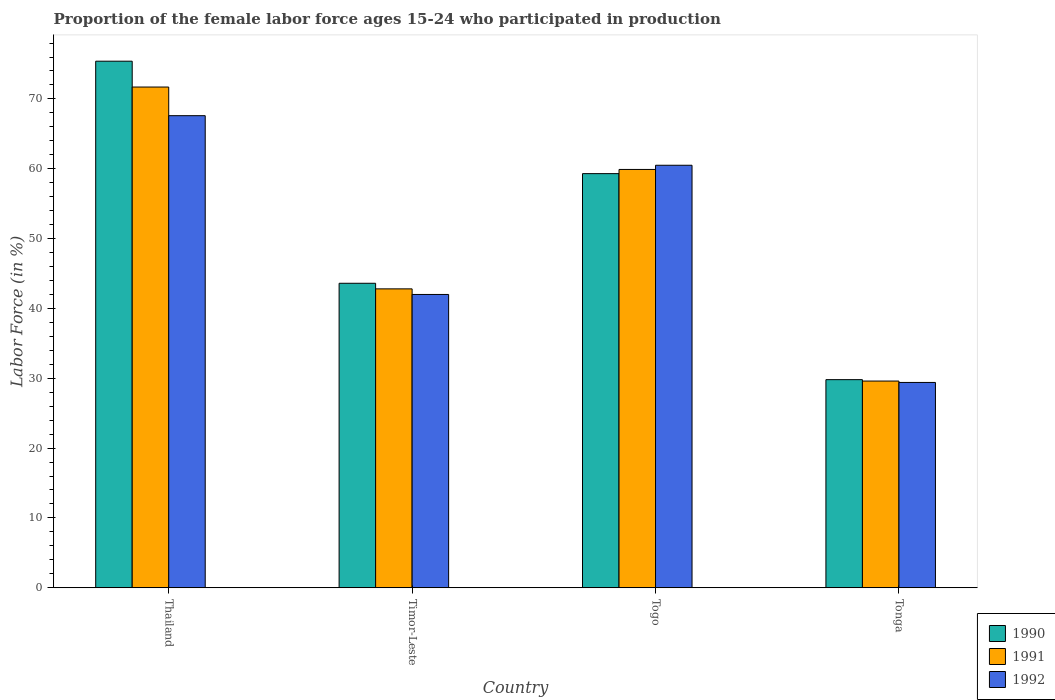How many different coloured bars are there?
Give a very brief answer. 3. Are the number of bars per tick equal to the number of legend labels?
Ensure brevity in your answer.  Yes. Are the number of bars on each tick of the X-axis equal?
Make the answer very short. Yes. How many bars are there on the 2nd tick from the left?
Give a very brief answer. 3. What is the label of the 4th group of bars from the left?
Provide a succinct answer. Tonga. In how many cases, is the number of bars for a given country not equal to the number of legend labels?
Your answer should be very brief. 0. What is the proportion of the female labor force who participated in production in 1990 in Timor-Leste?
Provide a succinct answer. 43.6. Across all countries, what is the maximum proportion of the female labor force who participated in production in 1992?
Give a very brief answer. 67.6. Across all countries, what is the minimum proportion of the female labor force who participated in production in 1990?
Provide a short and direct response. 29.8. In which country was the proportion of the female labor force who participated in production in 1991 maximum?
Provide a succinct answer. Thailand. In which country was the proportion of the female labor force who participated in production in 1991 minimum?
Offer a terse response. Tonga. What is the total proportion of the female labor force who participated in production in 1992 in the graph?
Offer a terse response. 199.5. What is the difference between the proportion of the female labor force who participated in production in 1990 in Thailand and that in Togo?
Offer a very short reply. 16.1. What is the difference between the proportion of the female labor force who participated in production in 1992 in Tonga and the proportion of the female labor force who participated in production in 1991 in Togo?
Provide a short and direct response. -30.5. What is the average proportion of the female labor force who participated in production in 1990 per country?
Your answer should be very brief. 52.02. What is the difference between the proportion of the female labor force who participated in production of/in 1990 and proportion of the female labor force who participated in production of/in 1992 in Thailand?
Your response must be concise. 7.8. In how many countries, is the proportion of the female labor force who participated in production in 1991 greater than 20 %?
Give a very brief answer. 4. What is the ratio of the proportion of the female labor force who participated in production in 1990 in Thailand to that in Tonga?
Your answer should be compact. 2.53. Is the difference between the proportion of the female labor force who participated in production in 1990 in Timor-Leste and Togo greater than the difference between the proportion of the female labor force who participated in production in 1992 in Timor-Leste and Togo?
Offer a very short reply. Yes. What is the difference between the highest and the second highest proportion of the female labor force who participated in production in 1991?
Offer a terse response. -17.1. What is the difference between the highest and the lowest proportion of the female labor force who participated in production in 1992?
Provide a succinct answer. 38.2. How many bars are there?
Give a very brief answer. 12. Are all the bars in the graph horizontal?
Your answer should be very brief. No. Does the graph contain any zero values?
Your answer should be very brief. No. Where does the legend appear in the graph?
Give a very brief answer. Bottom right. How are the legend labels stacked?
Your answer should be compact. Vertical. What is the title of the graph?
Provide a succinct answer. Proportion of the female labor force ages 15-24 who participated in production. What is the label or title of the Y-axis?
Make the answer very short. Labor Force (in %). What is the Labor Force (in %) in 1990 in Thailand?
Make the answer very short. 75.4. What is the Labor Force (in %) in 1991 in Thailand?
Ensure brevity in your answer.  71.7. What is the Labor Force (in %) of 1992 in Thailand?
Provide a short and direct response. 67.6. What is the Labor Force (in %) of 1990 in Timor-Leste?
Your answer should be very brief. 43.6. What is the Labor Force (in %) in 1991 in Timor-Leste?
Your answer should be compact. 42.8. What is the Labor Force (in %) in 1990 in Togo?
Offer a terse response. 59.3. What is the Labor Force (in %) in 1991 in Togo?
Your answer should be compact. 59.9. What is the Labor Force (in %) of 1992 in Togo?
Your answer should be very brief. 60.5. What is the Labor Force (in %) in 1990 in Tonga?
Offer a terse response. 29.8. What is the Labor Force (in %) in 1991 in Tonga?
Your answer should be very brief. 29.6. What is the Labor Force (in %) of 1992 in Tonga?
Offer a terse response. 29.4. Across all countries, what is the maximum Labor Force (in %) of 1990?
Your answer should be compact. 75.4. Across all countries, what is the maximum Labor Force (in %) of 1991?
Keep it short and to the point. 71.7. Across all countries, what is the maximum Labor Force (in %) of 1992?
Offer a terse response. 67.6. Across all countries, what is the minimum Labor Force (in %) in 1990?
Your answer should be compact. 29.8. Across all countries, what is the minimum Labor Force (in %) of 1991?
Keep it short and to the point. 29.6. Across all countries, what is the minimum Labor Force (in %) in 1992?
Your answer should be compact. 29.4. What is the total Labor Force (in %) in 1990 in the graph?
Ensure brevity in your answer.  208.1. What is the total Labor Force (in %) in 1991 in the graph?
Your answer should be very brief. 204. What is the total Labor Force (in %) in 1992 in the graph?
Offer a very short reply. 199.5. What is the difference between the Labor Force (in %) of 1990 in Thailand and that in Timor-Leste?
Make the answer very short. 31.8. What is the difference between the Labor Force (in %) in 1991 in Thailand and that in Timor-Leste?
Ensure brevity in your answer.  28.9. What is the difference between the Labor Force (in %) of 1992 in Thailand and that in Timor-Leste?
Provide a succinct answer. 25.6. What is the difference between the Labor Force (in %) in 1990 in Thailand and that in Togo?
Give a very brief answer. 16.1. What is the difference between the Labor Force (in %) of 1990 in Thailand and that in Tonga?
Provide a succinct answer. 45.6. What is the difference between the Labor Force (in %) of 1991 in Thailand and that in Tonga?
Keep it short and to the point. 42.1. What is the difference between the Labor Force (in %) in 1992 in Thailand and that in Tonga?
Provide a succinct answer. 38.2. What is the difference between the Labor Force (in %) in 1990 in Timor-Leste and that in Togo?
Provide a succinct answer. -15.7. What is the difference between the Labor Force (in %) in 1991 in Timor-Leste and that in Togo?
Provide a succinct answer. -17.1. What is the difference between the Labor Force (in %) in 1992 in Timor-Leste and that in Togo?
Your response must be concise. -18.5. What is the difference between the Labor Force (in %) of 1990 in Timor-Leste and that in Tonga?
Provide a succinct answer. 13.8. What is the difference between the Labor Force (in %) of 1991 in Timor-Leste and that in Tonga?
Your answer should be compact. 13.2. What is the difference between the Labor Force (in %) in 1990 in Togo and that in Tonga?
Ensure brevity in your answer.  29.5. What is the difference between the Labor Force (in %) in 1991 in Togo and that in Tonga?
Give a very brief answer. 30.3. What is the difference between the Labor Force (in %) in 1992 in Togo and that in Tonga?
Your response must be concise. 31.1. What is the difference between the Labor Force (in %) of 1990 in Thailand and the Labor Force (in %) of 1991 in Timor-Leste?
Your answer should be very brief. 32.6. What is the difference between the Labor Force (in %) of 1990 in Thailand and the Labor Force (in %) of 1992 in Timor-Leste?
Make the answer very short. 33.4. What is the difference between the Labor Force (in %) of 1991 in Thailand and the Labor Force (in %) of 1992 in Timor-Leste?
Your response must be concise. 29.7. What is the difference between the Labor Force (in %) of 1990 in Thailand and the Labor Force (in %) of 1992 in Togo?
Offer a terse response. 14.9. What is the difference between the Labor Force (in %) in 1991 in Thailand and the Labor Force (in %) in 1992 in Togo?
Keep it short and to the point. 11.2. What is the difference between the Labor Force (in %) in 1990 in Thailand and the Labor Force (in %) in 1991 in Tonga?
Provide a short and direct response. 45.8. What is the difference between the Labor Force (in %) of 1990 in Thailand and the Labor Force (in %) of 1992 in Tonga?
Your response must be concise. 46. What is the difference between the Labor Force (in %) in 1991 in Thailand and the Labor Force (in %) in 1992 in Tonga?
Your answer should be very brief. 42.3. What is the difference between the Labor Force (in %) of 1990 in Timor-Leste and the Labor Force (in %) of 1991 in Togo?
Provide a short and direct response. -16.3. What is the difference between the Labor Force (in %) of 1990 in Timor-Leste and the Labor Force (in %) of 1992 in Togo?
Ensure brevity in your answer.  -16.9. What is the difference between the Labor Force (in %) of 1991 in Timor-Leste and the Labor Force (in %) of 1992 in Togo?
Your response must be concise. -17.7. What is the difference between the Labor Force (in %) of 1991 in Timor-Leste and the Labor Force (in %) of 1992 in Tonga?
Offer a very short reply. 13.4. What is the difference between the Labor Force (in %) of 1990 in Togo and the Labor Force (in %) of 1991 in Tonga?
Offer a terse response. 29.7. What is the difference between the Labor Force (in %) in 1990 in Togo and the Labor Force (in %) in 1992 in Tonga?
Provide a succinct answer. 29.9. What is the difference between the Labor Force (in %) of 1991 in Togo and the Labor Force (in %) of 1992 in Tonga?
Offer a terse response. 30.5. What is the average Labor Force (in %) in 1990 per country?
Keep it short and to the point. 52.02. What is the average Labor Force (in %) of 1991 per country?
Your answer should be compact. 51. What is the average Labor Force (in %) of 1992 per country?
Your answer should be very brief. 49.88. What is the difference between the Labor Force (in %) in 1990 and Labor Force (in %) in 1992 in Timor-Leste?
Offer a very short reply. 1.6. What is the difference between the Labor Force (in %) in 1990 and Labor Force (in %) in 1991 in Togo?
Your answer should be very brief. -0.6. What is the difference between the Labor Force (in %) of 1990 and Labor Force (in %) of 1992 in Togo?
Ensure brevity in your answer.  -1.2. What is the difference between the Labor Force (in %) of 1991 and Labor Force (in %) of 1992 in Togo?
Offer a very short reply. -0.6. What is the difference between the Labor Force (in %) of 1990 and Labor Force (in %) of 1991 in Tonga?
Give a very brief answer. 0.2. What is the difference between the Labor Force (in %) of 1990 and Labor Force (in %) of 1992 in Tonga?
Make the answer very short. 0.4. What is the difference between the Labor Force (in %) of 1991 and Labor Force (in %) of 1992 in Tonga?
Give a very brief answer. 0.2. What is the ratio of the Labor Force (in %) in 1990 in Thailand to that in Timor-Leste?
Your response must be concise. 1.73. What is the ratio of the Labor Force (in %) of 1991 in Thailand to that in Timor-Leste?
Make the answer very short. 1.68. What is the ratio of the Labor Force (in %) of 1992 in Thailand to that in Timor-Leste?
Provide a succinct answer. 1.61. What is the ratio of the Labor Force (in %) of 1990 in Thailand to that in Togo?
Give a very brief answer. 1.27. What is the ratio of the Labor Force (in %) of 1991 in Thailand to that in Togo?
Make the answer very short. 1.2. What is the ratio of the Labor Force (in %) in 1992 in Thailand to that in Togo?
Provide a short and direct response. 1.12. What is the ratio of the Labor Force (in %) of 1990 in Thailand to that in Tonga?
Make the answer very short. 2.53. What is the ratio of the Labor Force (in %) of 1991 in Thailand to that in Tonga?
Offer a terse response. 2.42. What is the ratio of the Labor Force (in %) in 1992 in Thailand to that in Tonga?
Give a very brief answer. 2.3. What is the ratio of the Labor Force (in %) of 1990 in Timor-Leste to that in Togo?
Keep it short and to the point. 0.74. What is the ratio of the Labor Force (in %) in 1991 in Timor-Leste to that in Togo?
Provide a short and direct response. 0.71. What is the ratio of the Labor Force (in %) in 1992 in Timor-Leste to that in Togo?
Your answer should be very brief. 0.69. What is the ratio of the Labor Force (in %) in 1990 in Timor-Leste to that in Tonga?
Your answer should be compact. 1.46. What is the ratio of the Labor Force (in %) of 1991 in Timor-Leste to that in Tonga?
Offer a terse response. 1.45. What is the ratio of the Labor Force (in %) in 1992 in Timor-Leste to that in Tonga?
Your answer should be compact. 1.43. What is the ratio of the Labor Force (in %) in 1990 in Togo to that in Tonga?
Your response must be concise. 1.99. What is the ratio of the Labor Force (in %) in 1991 in Togo to that in Tonga?
Your answer should be very brief. 2.02. What is the ratio of the Labor Force (in %) of 1992 in Togo to that in Tonga?
Offer a very short reply. 2.06. What is the difference between the highest and the second highest Labor Force (in %) of 1991?
Keep it short and to the point. 11.8. What is the difference between the highest and the second highest Labor Force (in %) of 1992?
Keep it short and to the point. 7.1. What is the difference between the highest and the lowest Labor Force (in %) of 1990?
Give a very brief answer. 45.6. What is the difference between the highest and the lowest Labor Force (in %) of 1991?
Your response must be concise. 42.1. What is the difference between the highest and the lowest Labor Force (in %) in 1992?
Keep it short and to the point. 38.2. 